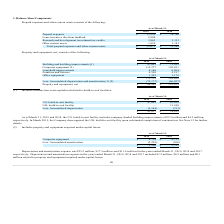According to Mimecast Limited's financial document, How much was the company-funded building improvements as of March 31, 2019? According to the financial document, $5.2 million. The relevant text states: "y includes company-funded building improvements of $5.2 million and $4.5 million,..." Also, How much was the company-funded building improvements as of March 31, 2018? According to the financial document, $4.5 million. The relevant text states: "y-funded building improvements of $5.2 million and $4.5 million,..." Also, When did the Company derecognized the U.K. build-to-suit facility upon substantial completion of construction? According to the financial document, March 2019. The relevant text states: "respectively. In March 2019, the Company derecognized the U.K. build-to-suit facility upon substantial completion of constructi..." Also, can you calculate: What is the change in U.S. build-to-suit facility from March 31, 2018 to March 31, 2019? Based on the calculation: 47,001-43,925, the result is 3076. This is based on the information: "U.S. build-to-suit facility $ 47,001 $ 43,925 Building and building improvements (1) $ 47,001 $ 75,165..." The key data points involved are: 43,925, 47,001. Also, can you calculate: What is the change in Accumulated depreciation from March 31, 2018 to March 31, 2019? Based on the calculation: 5,164-753, the result is 4411. This is based on the information: "Less: Accumulated depreciation (5,164) (753) Less: Accumulated depreciation (5,164) (753)..." The key data points involved are: 5,164, 753. Also, can you calculate: What is the average U.S. build-to-suit facility for March 31, 2018 to March 31, 2019? To answer this question, I need to perform calculations using the financial data. The calculation is: (47,001+43,925) / 2, which equals 45463. This is based on the information: "U.S. build-to-suit facility $ 47,001 $ 43,925 Building and building improvements (1) $ 47,001 $ 75,165..." The key data points involved are: 43,925, 47,001. 